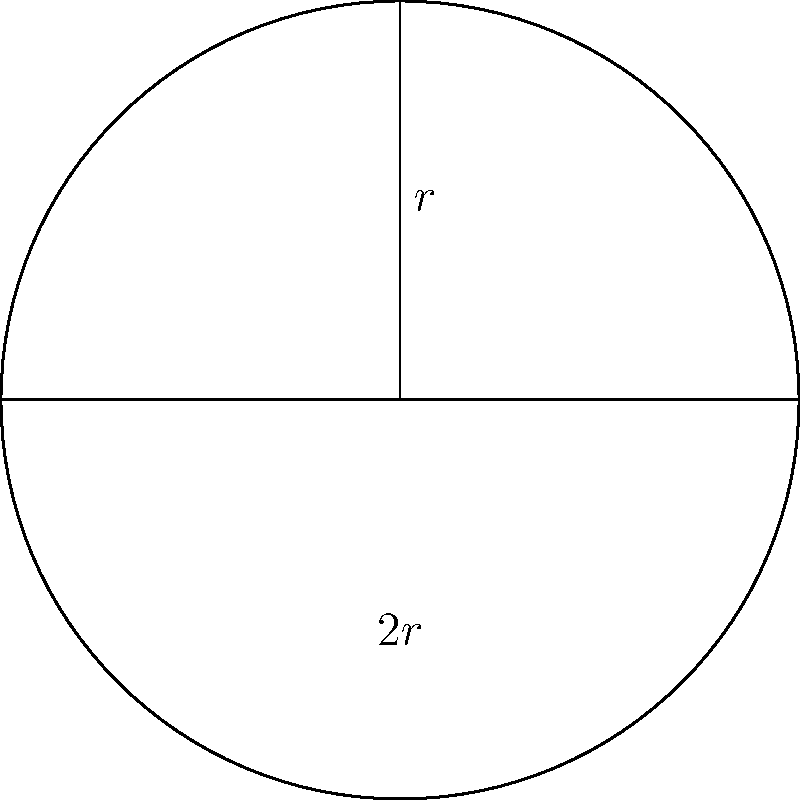A terrarium designer is creating a semi-spherical bowl terrarium. If the radius of the bowl is 15 cm, what is the maximum volume of water (in liters) that can be held in the terrarium if it is filled to the brim? To solve this problem, we need to follow these steps:

1) The volume of a semi-sphere is given by the formula:

   $V = \frac{2}{3}\pi r^3$

   Where $r$ is the radius of the sphere.

2) We are given that the radius is 15 cm. Let's substitute this into our formula:

   $V = \frac{2}{3}\pi (15\text{ cm})^3$

3) Let's calculate this step by step:
   
   $V = \frac{2}{3}\pi (3375\text{ cm}^3)$
   
   $V = 2250\pi\text{ cm}^3$

4) Now, let's calculate this:
   
   $V \approx 7068.58\text{ cm}^3$

5) The question asks for the volume in liters. We know that:
   
   $1\text{ liter} = 1000\text{ cm}^3$

6) So, we need to divide our result by 1000:

   $7068.58\text{ cm}^3 \div 1000 = 7.06858\text{ liters}$

7) Rounding to two decimal places:

   $7.07\text{ liters}$

This is the maximum volume of water that can be held in the terrarium if it is filled to the brim.
Answer: 7.07 liters 